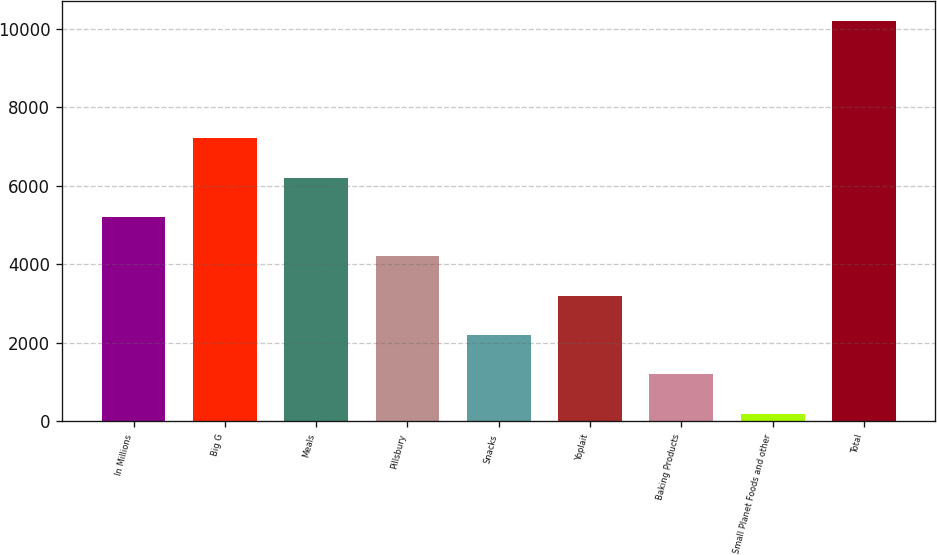<chart> <loc_0><loc_0><loc_500><loc_500><bar_chart><fcel>In Millions<fcel>Big G<fcel>Meals<fcel>Pillsbury<fcel>Snacks<fcel>Yoplait<fcel>Baking Products<fcel>Small Planet Foods and other<fcel>Total<nl><fcel>5205.95<fcel>7207.49<fcel>6206.72<fcel>4205.18<fcel>2203.64<fcel>3204.41<fcel>1202.87<fcel>202.1<fcel>10209.8<nl></chart> 